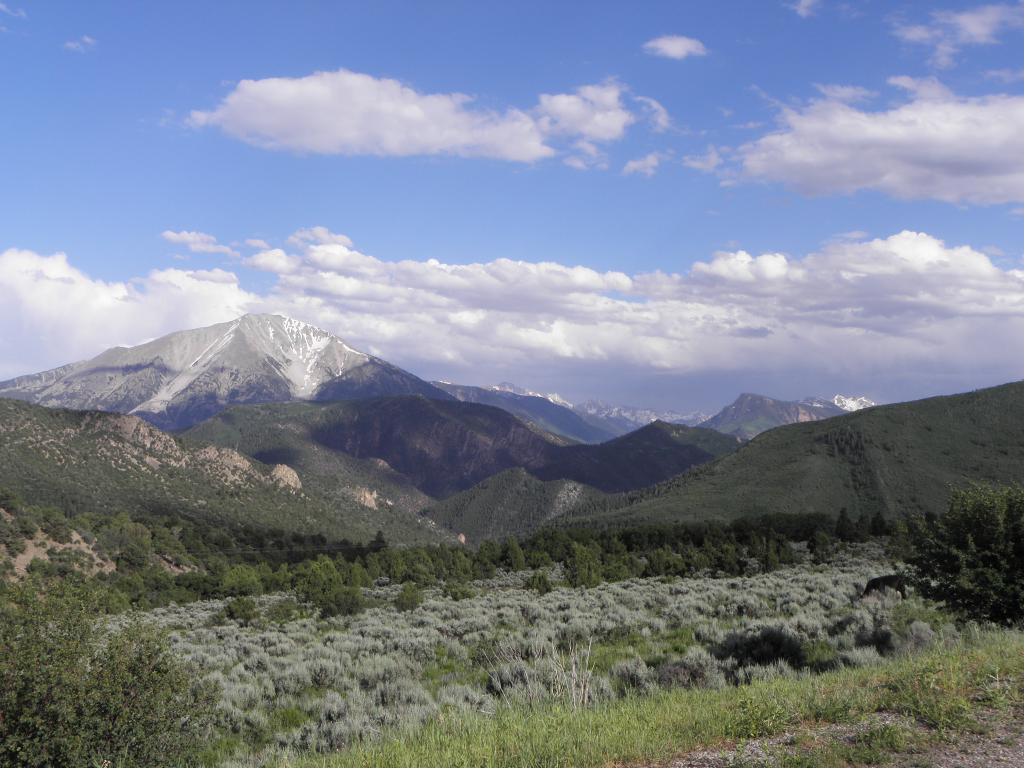What type of vegetation can be seen in the image? There are trees and plants in the image. What can be seen in the background of the image? There are hills, mountains, and the sky visible in the background of the image. What is the condition of the sky in the image? The sky is visible in the background of the image, and clouds are present. How many goldfish can be seen swimming in the image? There are no goldfish present in the image. What position are the dogs in the image? There are no dogs present in the image. 